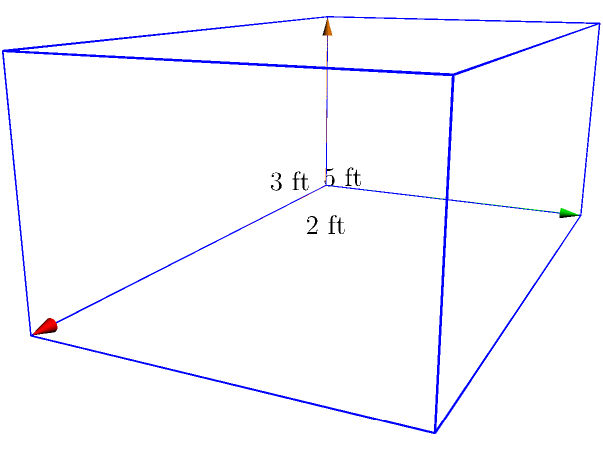As a Broadway actor, you need a storage box for your costumes. The rectangular prism-shaped box measures 5 feet in length, 3 feet in width, and 2 feet in height. What is the volume of this costume storage box in cubic feet? To find the volume of a rectangular prism, we use the formula:

$$V = l \times w \times h$$

Where:
$V$ = volume
$l$ = length
$w$ = width
$h$ = height

Given dimensions:
Length ($l$) = 5 feet
Width ($w$) = 3 feet
Height ($h$) = 2 feet

Let's substitute these values into the formula:

$$V = 5 \times 3 \times 2$$

Now, let's calculate:

$$V = 30$$

Therefore, the volume of the costume storage box is 30 cubic feet.
Answer: 30 cubic feet 